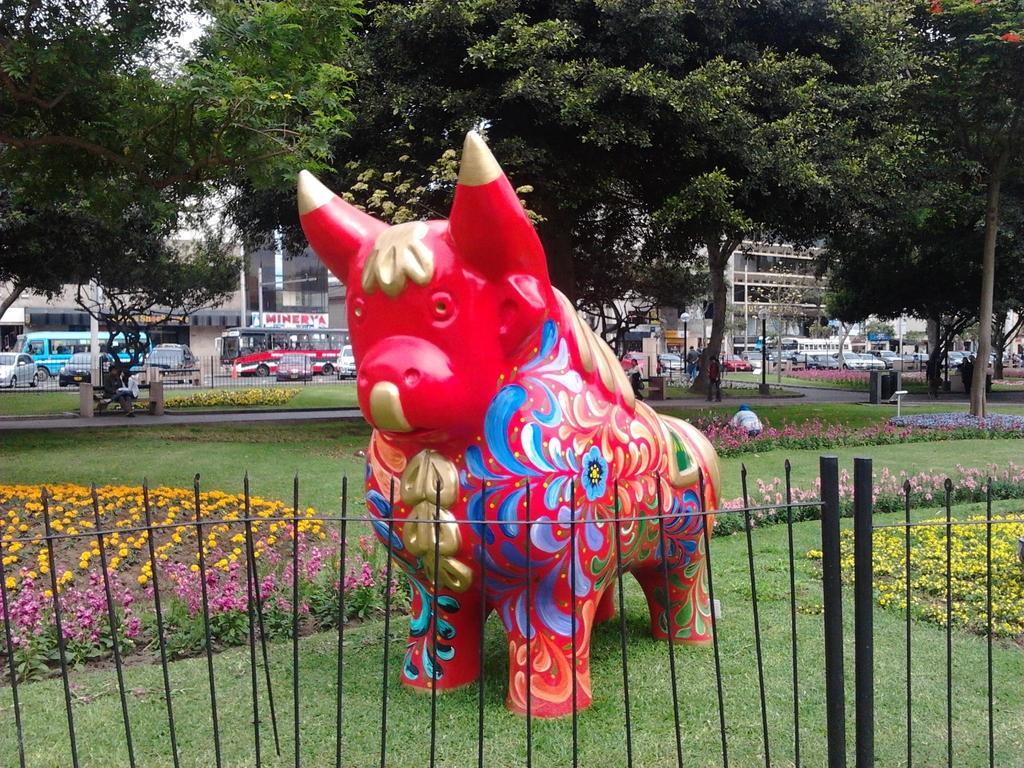In one or two sentences, can you explain what this image depicts? In the center of image there is a depiction of a animal. In the background of the image there are trees, buildings and cars. In the bottom of the image there is a fencing and grass. 